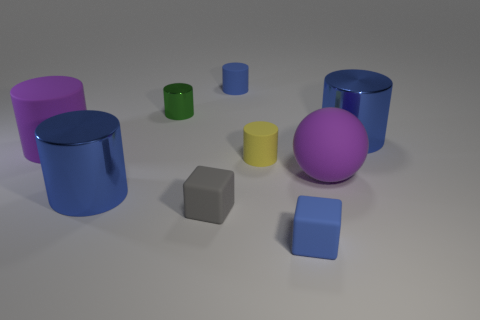Subtract all red blocks. How many blue cylinders are left? 3 Subtract all purple cylinders. How many cylinders are left? 5 Subtract all yellow cylinders. How many cylinders are left? 5 Subtract 2 cylinders. How many cylinders are left? 4 Subtract all gray cylinders. Subtract all yellow cubes. How many cylinders are left? 6 Add 1 big blue cylinders. How many objects exist? 10 Subtract all cylinders. How many objects are left? 3 Add 5 tiny yellow things. How many tiny yellow things exist? 6 Subtract 0 brown cubes. How many objects are left? 9 Subtract all objects. Subtract all tiny gray metal cylinders. How many objects are left? 0 